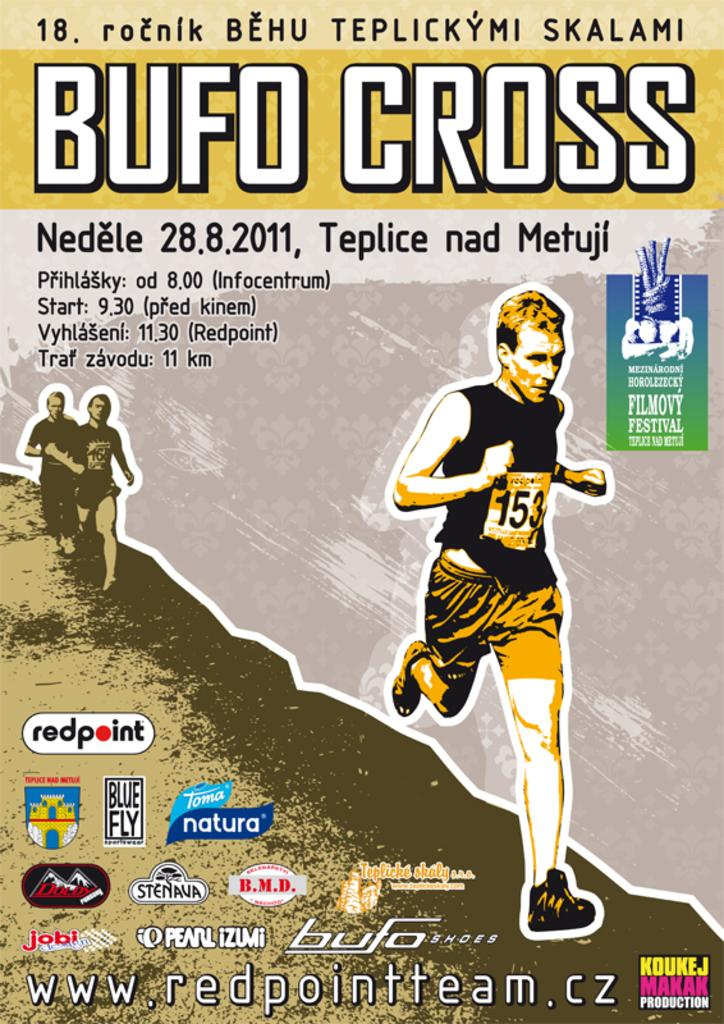What is the main subject of the image? The main subject of the image is a poster. What type of images are present on the poster? The poster contains pictures of persons. Are there any symbols on the poster? Yes, the poster includes logo symbols. What else can be seen on the poster besides images and symbols? The poster has text on it. Can you see a brush being used in the image? There is no brush present in the image. What is the limit of the persons shown on the poster? The image does not provide information about a limit for the number of persons shown on the poster. 